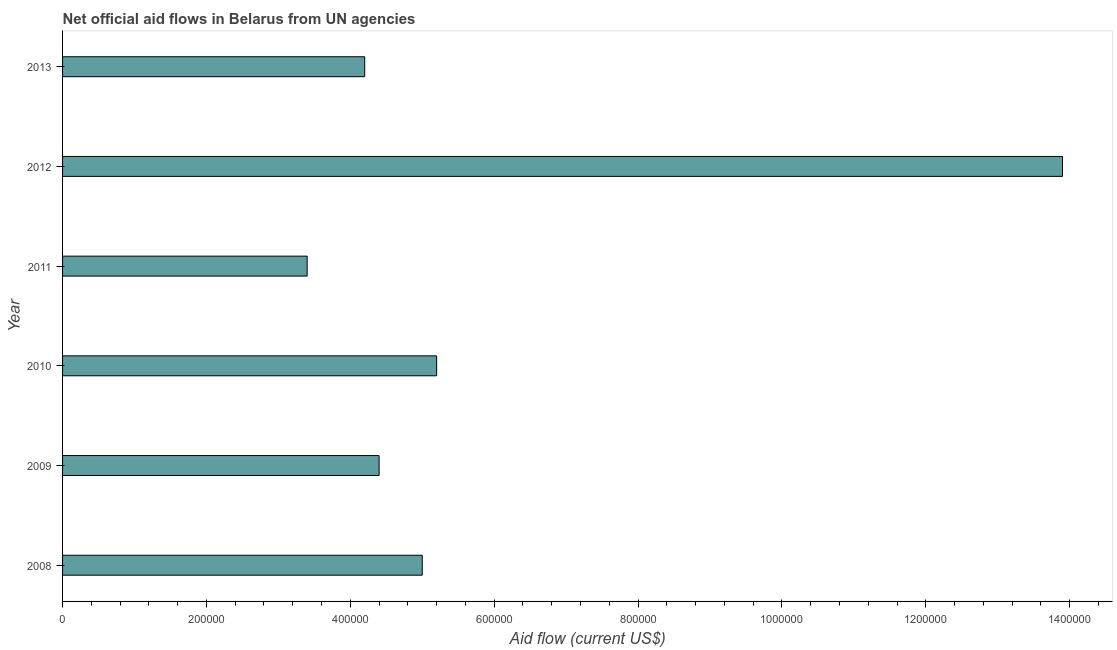Does the graph contain any zero values?
Keep it short and to the point. No. Does the graph contain grids?
Your answer should be compact. No. What is the title of the graph?
Offer a terse response. Net official aid flows in Belarus from UN agencies. What is the net official flows from un agencies in 2012?
Keep it short and to the point. 1.39e+06. Across all years, what is the maximum net official flows from un agencies?
Make the answer very short. 1.39e+06. In which year was the net official flows from un agencies maximum?
Make the answer very short. 2012. In which year was the net official flows from un agencies minimum?
Provide a short and direct response. 2011. What is the sum of the net official flows from un agencies?
Ensure brevity in your answer.  3.61e+06. What is the difference between the net official flows from un agencies in 2010 and 2012?
Offer a terse response. -8.70e+05. What is the average net official flows from un agencies per year?
Your answer should be very brief. 6.02e+05. What is the median net official flows from un agencies?
Your answer should be very brief. 4.70e+05. What is the ratio of the net official flows from un agencies in 2010 to that in 2013?
Ensure brevity in your answer.  1.24. Is the net official flows from un agencies in 2008 less than that in 2011?
Give a very brief answer. No. Is the difference between the net official flows from un agencies in 2008 and 2012 greater than the difference between any two years?
Provide a short and direct response. No. What is the difference between the highest and the second highest net official flows from un agencies?
Provide a short and direct response. 8.70e+05. Is the sum of the net official flows from un agencies in 2009 and 2013 greater than the maximum net official flows from un agencies across all years?
Offer a terse response. No. What is the difference between the highest and the lowest net official flows from un agencies?
Offer a very short reply. 1.05e+06. How many bars are there?
Ensure brevity in your answer.  6. Are the values on the major ticks of X-axis written in scientific E-notation?
Your answer should be compact. No. What is the Aid flow (current US$) in 2008?
Keep it short and to the point. 5.00e+05. What is the Aid flow (current US$) in 2010?
Provide a succinct answer. 5.20e+05. What is the Aid flow (current US$) of 2011?
Provide a succinct answer. 3.40e+05. What is the Aid flow (current US$) in 2012?
Your answer should be compact. 1.39e+06. What is the difference between the Aid flow (current US$) in 2008 and 2009?
Your answer should be very brief. 6.00e+04. What is the difference between the Aid flow (current US$) in 2008 and 2010?
Provide a short and direct response. -2.00e+04. What is the difference between the Aid flow (current US$) in 2008 and 2012?
Offer a terse response. -8.90e+05. What is the difference between the Aid flow (current US$) in 2009 and 2010?
Your answer should be very brief. -8.00e+04. What is the difference between the Aid flow (current US$) in 2009 and 2012?
Offer a terse response. -9.50e+05. What is the difference between the Aid flow (current US$) in 2009 and 2013?
Keep it short and to the point. 2.00e+04. What is the difference between the Aid flow (current US$) in 2010 and 2012?
Your answer should be compact. -8.70e+05. What is the difference between the Aid flow (current US$) in 2010 and 2013?
Ensure brevity in your answer.  1.00e+05. What is the difference between the Aid flow (current US$) in 2011 and 2012?
Provide a succinct answer. -1.05e+06. What is the difference between the Aid flow (current US$) in 2012 and 2013?
Your answer should be very brief. 9.70e+05. What is the ratio of the Aid flow (current US$) in 2008 to that in 2009?
Your answer should be very brief. 1.14. What is the ratio of the Aid flow (current US$) in 2008 to that in 2010?
Give a very brief answer. 0.96. What is the ratio of the Aid flow (current US$) in 2008 to that in 2011?
Offer a very short reply. 1.47. What is the ratio of the Aid flow (current US$) in 2008 to that in 2012?
Provide a succinct answer. 0.36. What is the ratio of the Aid flow (current US$) in 2008 to that in 2013?
Offer a very short reply. 1.19. What is the ratio of the Aid flow (current US$) in 2009 to that in 2010?
Offer a terse response. 0.85. What is the ratio of the Aid flow (current US$) in 2009 to that in 2011?
Your answer should be very brief. 1.29. What is the ratio of the Aid flow (current US$) in 2009 to that in 2012?
Ensure brevity in your answer.  0.32. What is the ratio of the Aid flow (current US$) in 2009 to that in 2013?
Provide a succinct answer. 1.05. What is the ratio of the Aid flow (current US$) in 2010 to that in 2011?
Offer a very short reply. 1.53. What is the ratio of the Aid flow (current US$) in 2010 to that in 2012?
Provide a short and direct response. 0.37. What is the ratio of the Aid flow (current US$) in 2010 to that in 2013?
Your answer should be very brief. 1.24. What is the ratio of the Aid flow (current US$) in 2011 to that in 2012?
Your response must be concise. 0.24. What is the ratio of the Aid flow (current US$) in 2011 to that in 2013?
Your response must be concise. 0.81. What is the ratio of the Aid flow (current US$) in 2012 to that in 2013?
Your response must be concise. 3.31. 